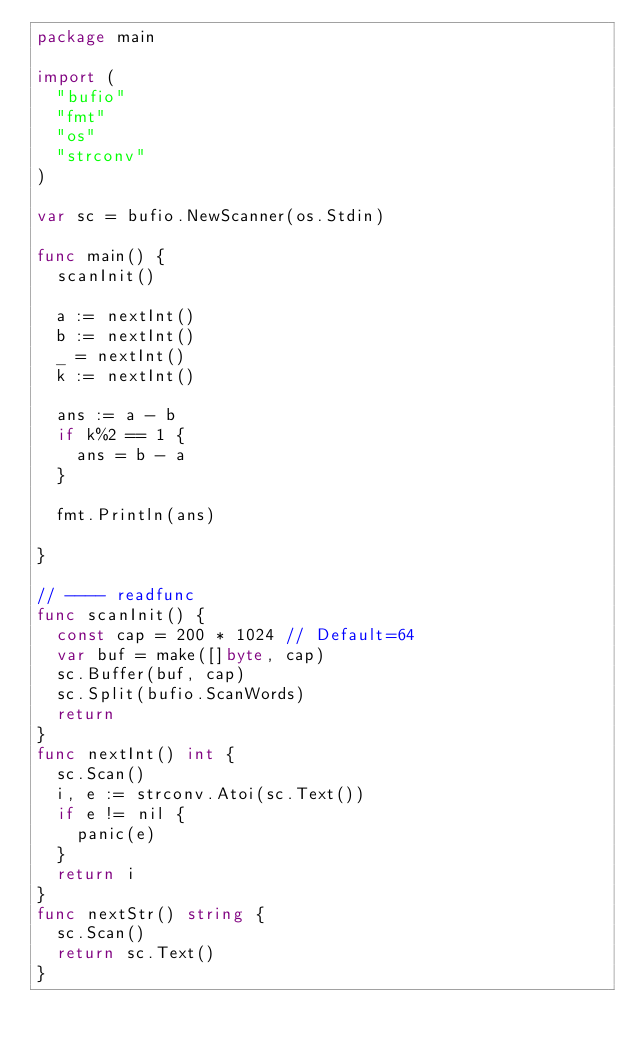<code> <loc_0><loc_0><loc_500><loc_500><_Go_>package main

import (
	"bufio"
	"fmt"
	"os"
	"strconv"
)

var sc = bufio.NewScanner(os.Stdin)

func main() {
	scanInit()

	a := nextInt()
	b := nextInt()
	_ = nextInt()
	k := nextInt()

	ans := a - b
	if k%2 == 1 {
		ans = b - a
	}

	fmt.Println(ans)

}

// ---- readfunc
func scanInit() {
	const cap = 200 * 1024 // Default=64
	var buf = make([]byte, cap)
	sc.Buffer(buf, cap)
	sc.Split(bufio.ScanWords)
	return
}
func nextInt() int {
	sc.Scan()
	i, e := strconv.Atoi(sc.Text())
	if e != nil {
		panic(e)
	}
	return i
}
func nextStr() string {
	sc.Scan()
	return sc.Text()
}
</code> 